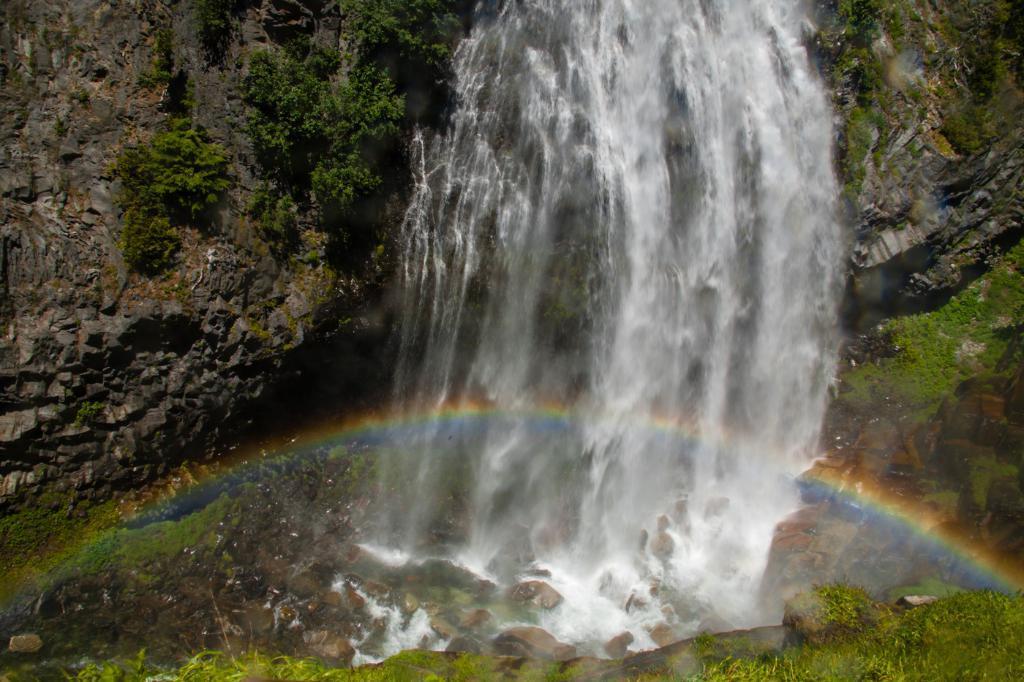Please provide a concise description of this image. In this picture I can see waterfall from the rock, down we can see some rocks and grass. 